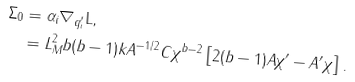<formula> <loc_0><loc_0><loc_500><loc_500>\Sigma _ { 0 } & = \alpha _ { i } \nabla _ { q _ { i } ^ { \prime } } { \mathrm L } , \\ & = L _ { M } ^ { 2 } b ( b - 1 ) k A ^ { - 1 / 2 } C \chi ^ { b - 2 } \left [ 2 ( b - 1 ) A \chi ^ { \prime } - A ^ { \prime } \chi \right ] .</formula> 